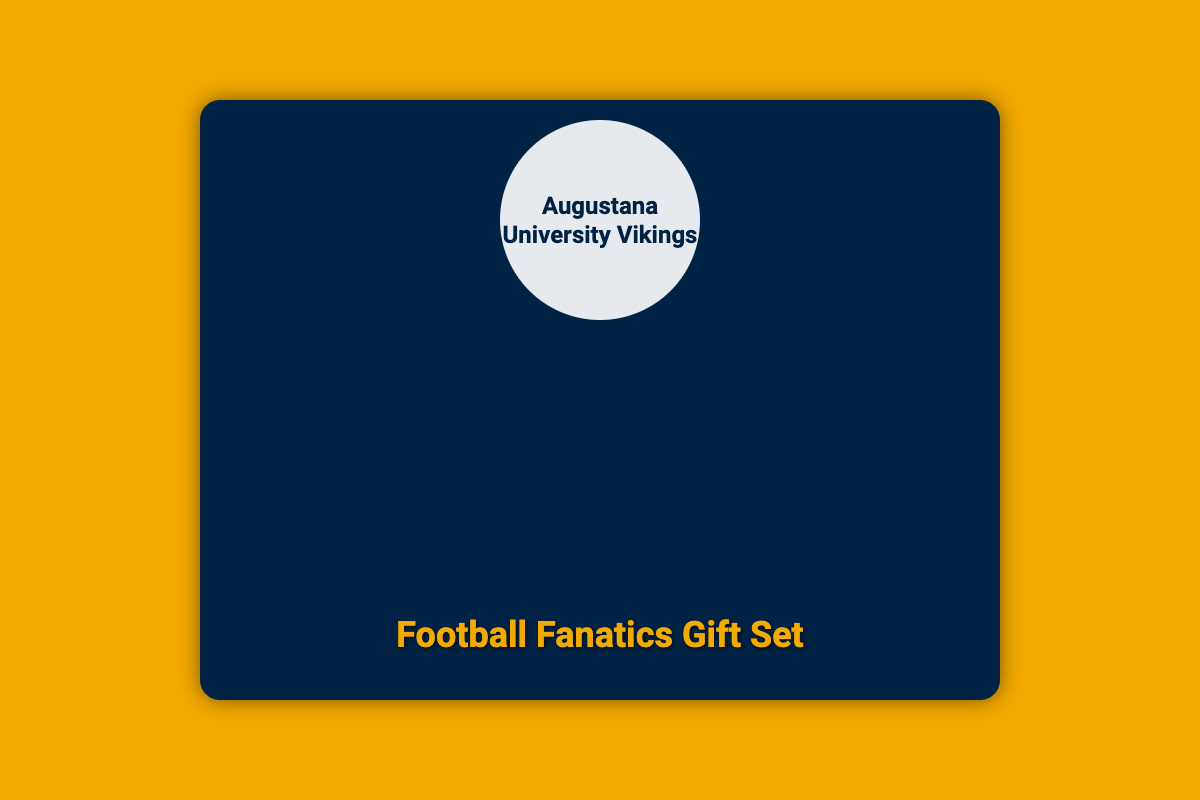what is included in the gift set? The document lists the specific items included in the gift set: Mini Helmet, Autographed Football, Vikings T-Shirt, and Historical Game Highlights.
Answer: Mini Helmet, Autographed Football, Vikings T-Shirt, Historical Game Highlights who signed the autographed football? The autographed football is signed by former Vikings quarterback Trey Heid.
Answer: Trey Heid what colors are featured on the mini helmet? The document mentions that the mini helmet features the classic navy and gold colors of Augustana University.
Answer: Navy and gold which game is highlighted in the historical game highlights booklet? The booklet features detailed highlights from legendary games, specifically mentioning the 2016 Mineral Water Bowl victory.
Answer: 2016 Mineral Water Bowl victory what slogan is on the Vikings T-Shirt? The document states that the T-Shirt is emblazoned with the 'Go Vikings!' slogan.
Answer: Go Vikings! how many photos are in the photo collage? The photo collage displays three images related to football moments.
Answer: Three what type of packaging is this document describing? The document is describing packaging for a gift set specifically designed for American football fans and alumni of Augustana University.
Answer: Gift set packaging what sport does the logo represent? The logo represents the Augustana University Vikings, which is associated with American football.
Answer: American football 